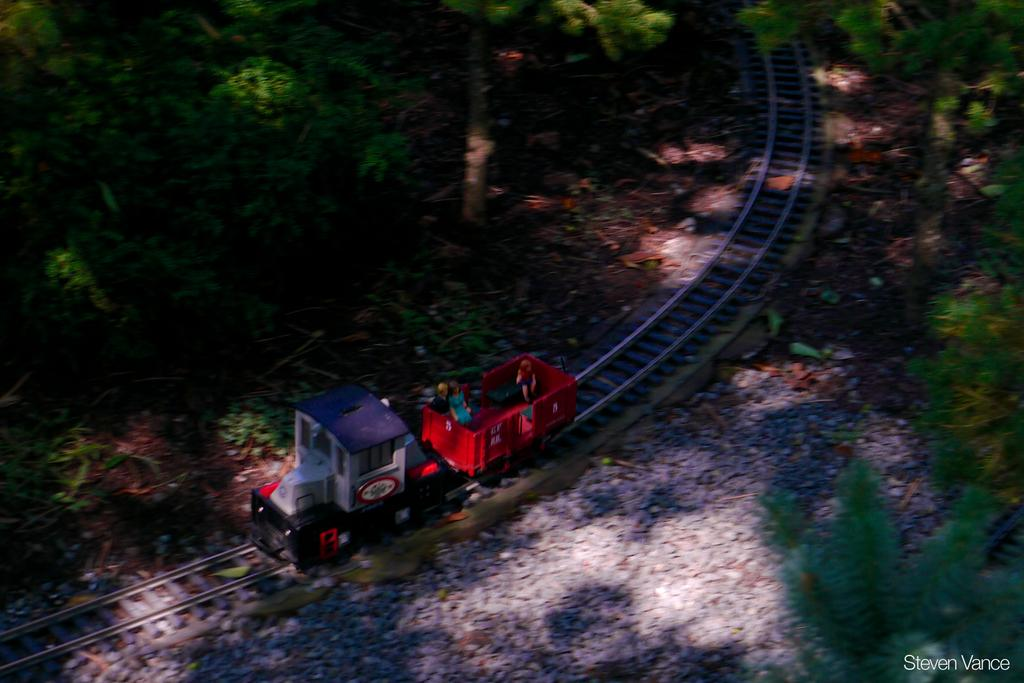What type of toy is present in the image? There is a toy train in the image. What other elements can be seen in the image besides the toy train? There are plants and stones in the image. How does the tiger contribute to the peace in the image? There is no tiger present in the image, so it cannot contribute to the peace. 